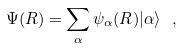Convert formula to latex. <formula><loc_0><loc_0><loc_500><loc_500>\Psi ( { R } ) = \sum _ { \alpha } \psi _ { \alpha } ( { R } ) | \alpha \rangle \ ,</formula> 